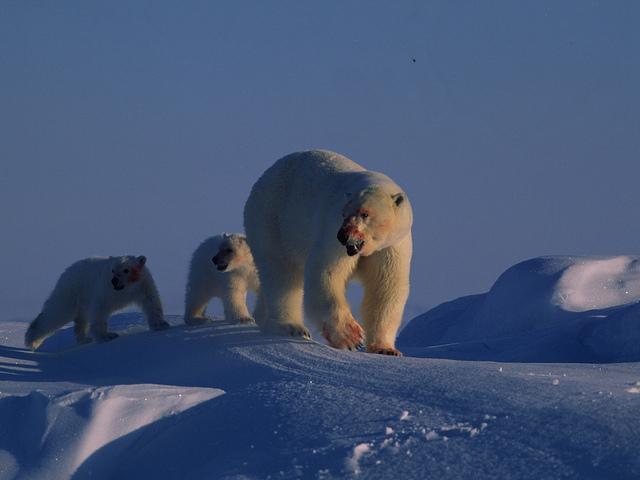Red on this bears face comes from it's what?
Indicate the correct response and explain using: 'Answer: answer
Rationale: rationale.'
Options: Tail, prey, sunburn, cub. Answer: prey.
Rationale: Bears eat other animals. animals have blood in them. blood is red. 